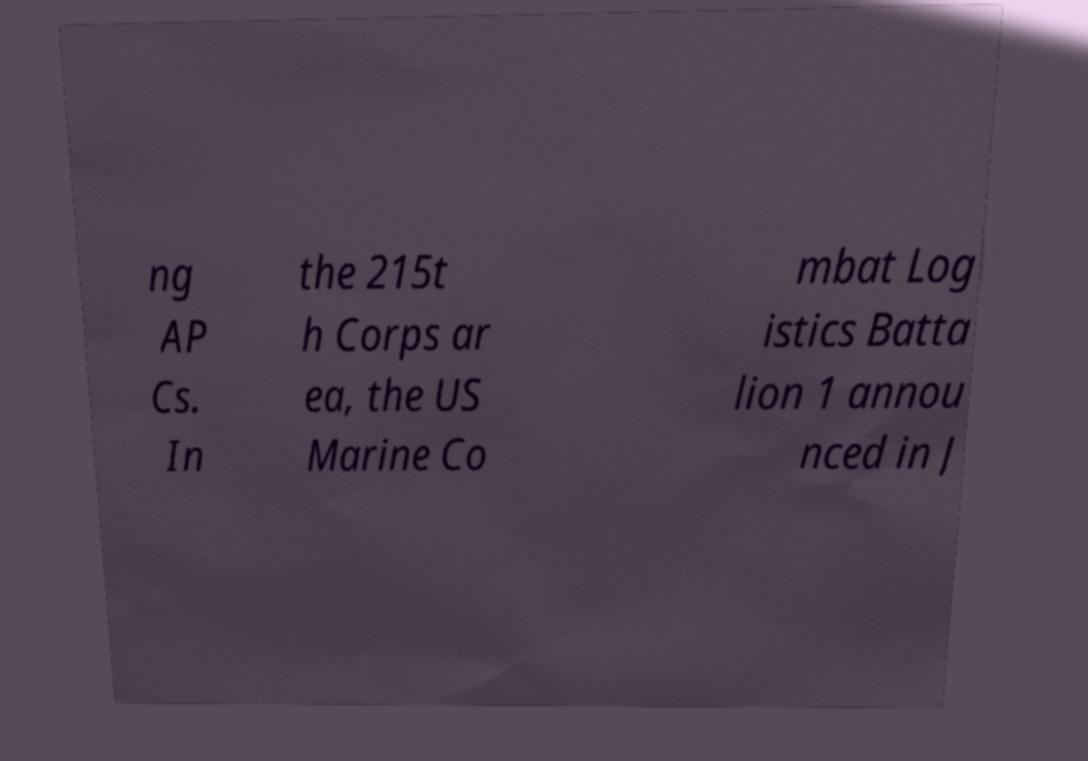Can you read and provide the text displayed in the image?This photo seems to have some interesting text. Can you extract and type it out for me? ng AP Cs. In the 215t h Corps ar ea, the US Marine Co mbat Log istics Batta lion 1 annou nced in J 